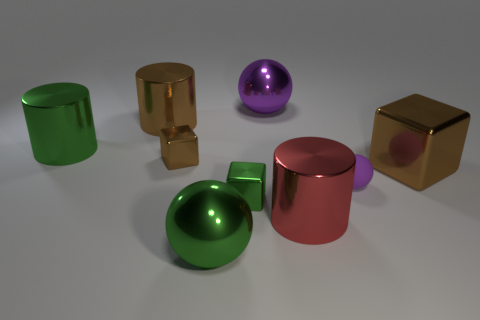Subtract all blocks. How many objects are left? 6 Add 1 red rubber things. How many red rubber things exist? 1 Subtract 0 yellow cylinders. How many objects are left? 9 Subtract all tiny green cubes. Subtract all red cylinders. How many objects are left? 7 Add 4 tiny cubes. How many tiny cubes are left? 6 